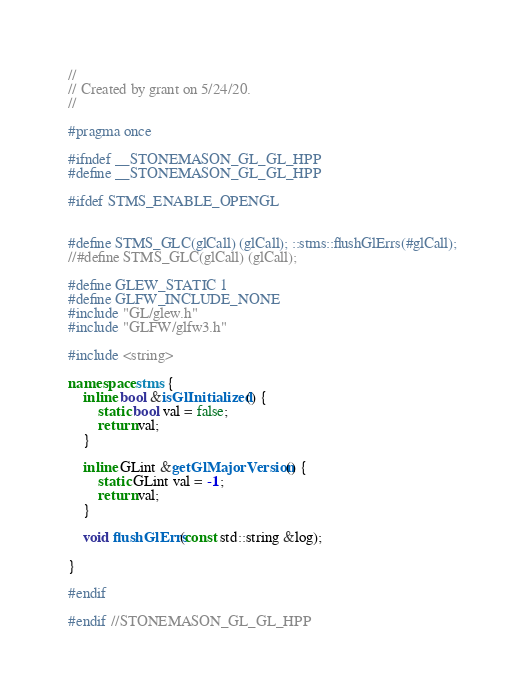<code> <loc_0><loc_0><loc_500><loc_500><_C++_>//
// Created by grant on 5/24/20.
//

#pragma once

#ifndef __STONEMASON_GL_GL_HPP
#define __STONEMASON_GL_GL_HPP

#ifdef STMS_ENABLE_OPENGL


#define STMS_GLC(glCall) (glCall); ::stms::flushGlErrs(#glCall);
//#define STMS_GLC(glCall) (glCall);

#define GLEW_STATIC 1
#define GLFW_INCLUDE_NONE
#include "GL/glew.h"
#include "GLFW/glfw3.h"

#include <string>

namespace stms {
    inline bool &isGlInitialized() {
        static bool val = false;
        return val;
    }

    inline GLint &getGlMajorVersion() {
        static GLint val = -1;
        return val;
    }

    void flushGlErrs(const std::string &log);

}

#endif

#endif //STONEMASON_GL_GL_HPP
</code> 